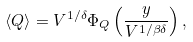Convert formula to latex. <formula><loc_0><loc_0><loc_500><loc_500>\langle Q \rangle = V ^ { 1 / \delta } \Phi _ { Q } \left ( \frac { y } { V ^ { 1 / \beta \delta } } \right ) ,</formula> 